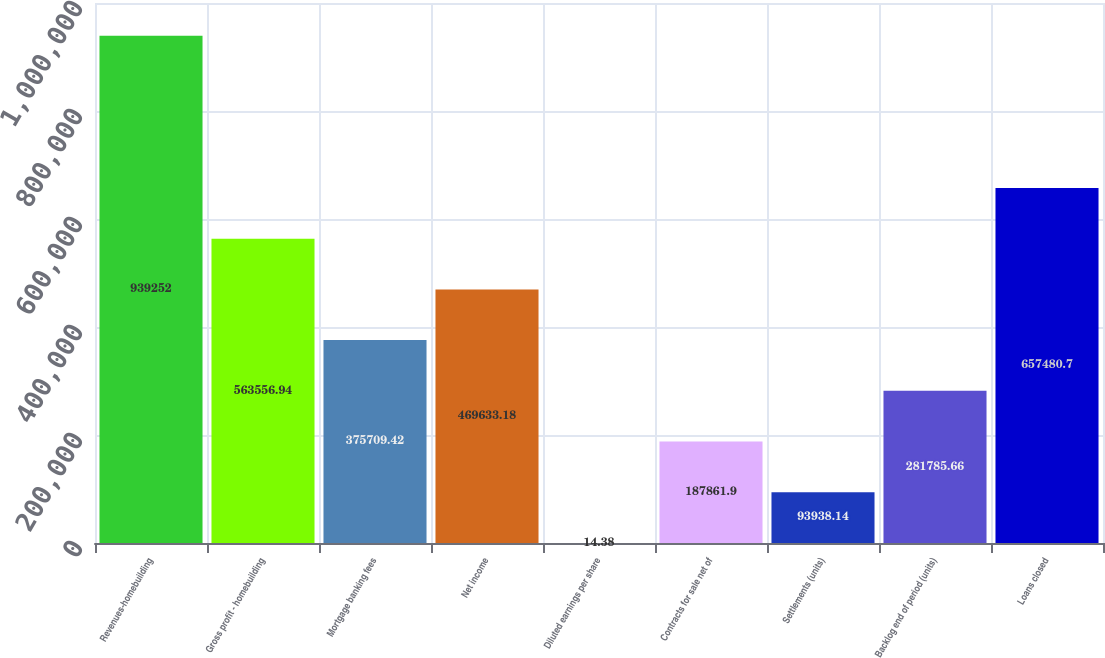<chart> <loc_0><loc_0><loc_500><loc_500><bar_chart><fcel>Revenues-homebuilding<fcel>Gross profit - homebuilding<fcel>Mortgage banking fees<fcel>Net income<fcel>Diluted earnings per share<fcel>Contracts for sale net of<fcel>Settlements (units)<fcel>Backlog end of period (units)<fcel>Loans closed<nl><fcel>939252<fcel>563557<fcel>375709<fcel>469633<fcel>14.38<fcel>187862<fcel>93938.1<fcel>281786<fcel>657481<nl></chart> 